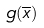<formula> <loc_0><loc_0><loc_500><loc_500>g ( \overline { x } )</formula> 